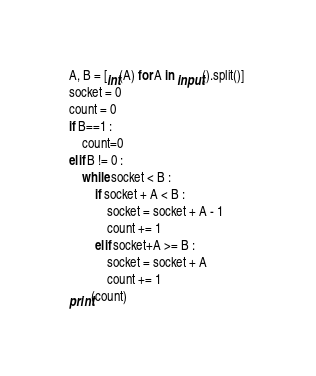<code> <loc_0><loc_0><loc_500><loc_500><_Python_>A, B = [int(A) for A in input().split()] 
socket = 0
count = 0
if B==1 :
    count=0
elif B != 0 :
    while socket < B :
        if socket + A < B :
            socket = socket + A - 1
            count += 1
        elif socket+A >= B :
            socket = socket + A
            count += 1
print(count)
</code> 